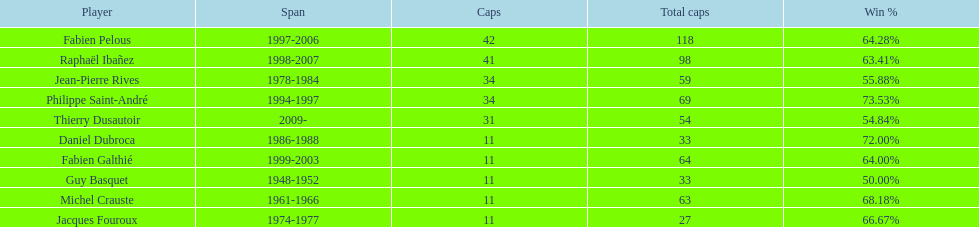How many caps did jean-pierre rives and michel crauste accrue? 122. 